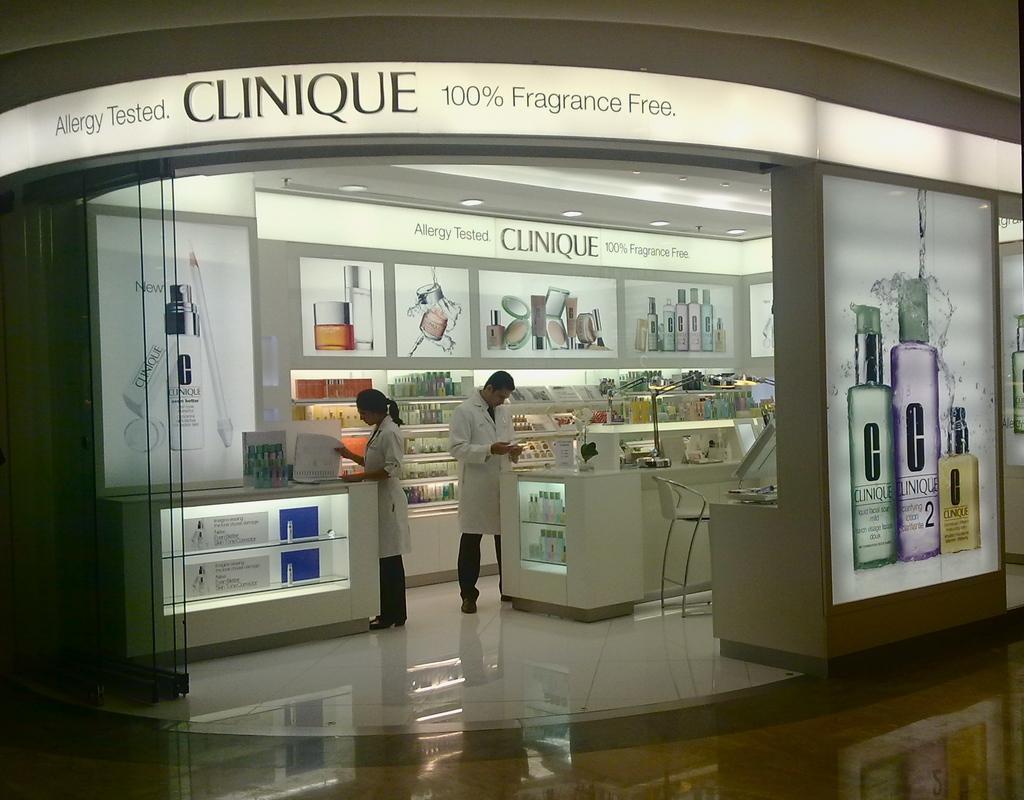Describe this image in one or two sentences. This picture is clicked inside. On the right we can see the pictures of bottles on the wall of a building. In the center we can see the text on the building and there are two persons standing on the ground and seems to be working and we can see the tables containing many number of items. In the background there is a roof, ceiling lights and the posters attached to the wall on which we can see the pictures of bottles and some other objects. 